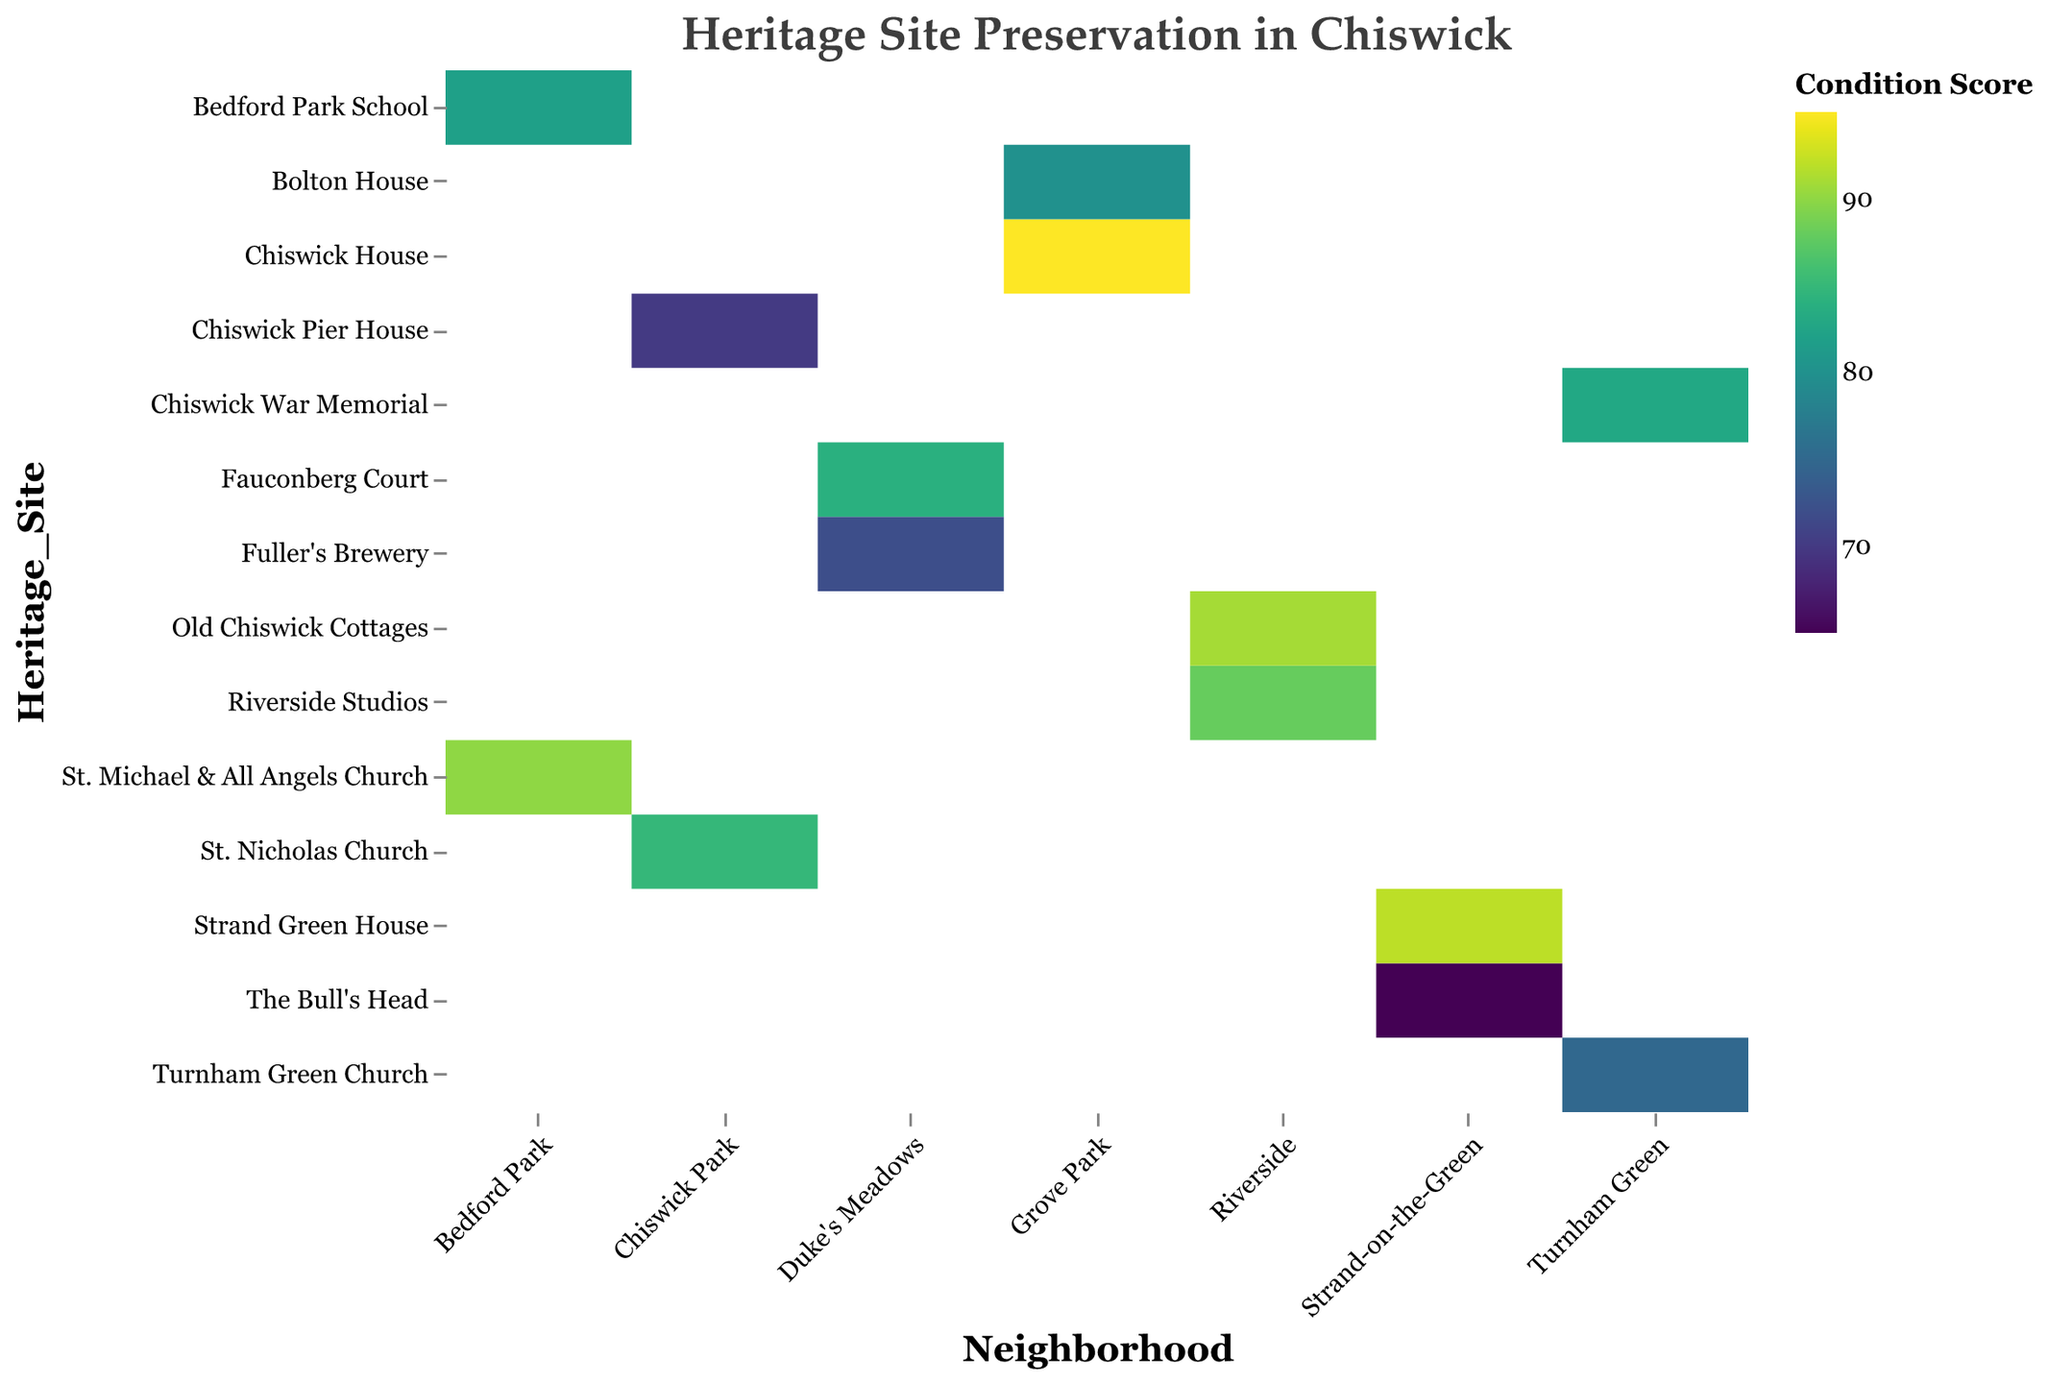What is the title of the figure? The title is usually located at the top of the figure and provides a brief description of what the figure is about. Here, the title is "Heritage Site Preservation in Chiswick."
Answer: Heritage Site Preservation in Chiswick Which heritage site in Riverside has the highest condition score? We look at the column for Riverside and identify the highest condition score. It is 91 for Old Chiswick Cottages.
Answer: Old Chiswick Cottages What are the preservation statuses displayed in the heatmap? We examine the legend and tooltip details to find the different preservation statuses. They are Excellent, Good, and Moderate.
Answer: Excellent, Good, Moderate How does the condition score of Chiswick House compare to that of Fuller's Brewery? Identify the condition scores for both Chiswick House (95) and Fuller's Brewery (72). Chiswick House has a higher score than Fuller's Brewery.
Answer: Chiswick House has a higher score Which neighborhood has the highest average condition score for its heritage sites? Calculate the average condition score for the heritage sites within each neighborhood. Here are the averages: Grove Park (87.5), Chiswick Park (77.5), Bedford Park (86), Strand-on-the-Green (78.5), Turnham Green (79), Riverside (89.5), Duke's Meadows (78). Riverside has the highest average score.
Answer: Riverside Which heritage site in Bedford Park has an excellent preservation status? Check the heritage sites in Bedford Park and identify those with an excellent preservation status. St. Michael & All Angels Church is the one.
Answer: St. Michael & All Angels Church How many heritage sites have a condition score of 70 or below? Count the heritage sites with condition scores of 70 or below. They are Chiswick Pier House (70) and The Bull's Head (65). There are 2 sites.
Answer: 2 Is there a heritage site with an excellent preservation status and a condition score below 90? Check for heritage sites with excellent preservation status and condition scores below 90. There are no such sites in the provided data.
Answer: No What is the condition score of Bedford Park School? Look for the row corresponding to Bedford Park School and find its condition score. It is 82.
Answer: 82 Which neighborhood has the most heritage sites with a moderate preservation status? Count the heritage sites with moderate preservation status in each neighborhood. Strand-on-the-Green (1), Riverside (0), Chiswick Park (1), Turnham Green (1), Grove Park (0), Bedford Park (0), Duke's Meadows (1). All these neighborhoods except Riverside and Bedford Park have 1 each. Therefore, no single neighborhood has the most.
Answer: None; multiple neighborhoods have 1 each 